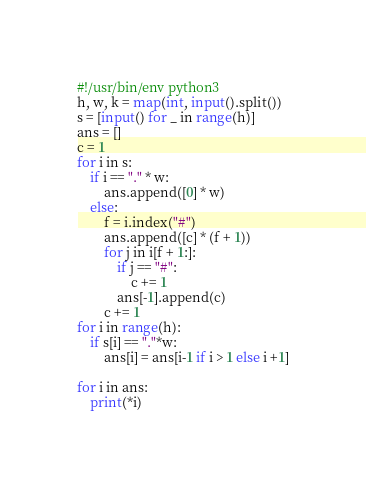Convert code to text. <code><loc_0><loc_0><loc_500><loc_500><_Python_>#!/usr/bin/env python3
h, w, k = map(int, input().split())
s = [input() for _ in range(h)]
ans = []
c = 1
for i in s:
    if i == "." * w:
        ans.append([0] * w)
    else:
        f = i.index("#")
        ans.append([c] * (f + 1))
        for j in i[f + 1:]:
            if j == "#":
                c += 1
            ans[-1].append(c)
        c += 1
for i in range(h):
    if s[i] == "."*w:
        ans[i] = ans[i-1 if i > 1 else i +1]

for i in ans:
    print(*i)
</code> 